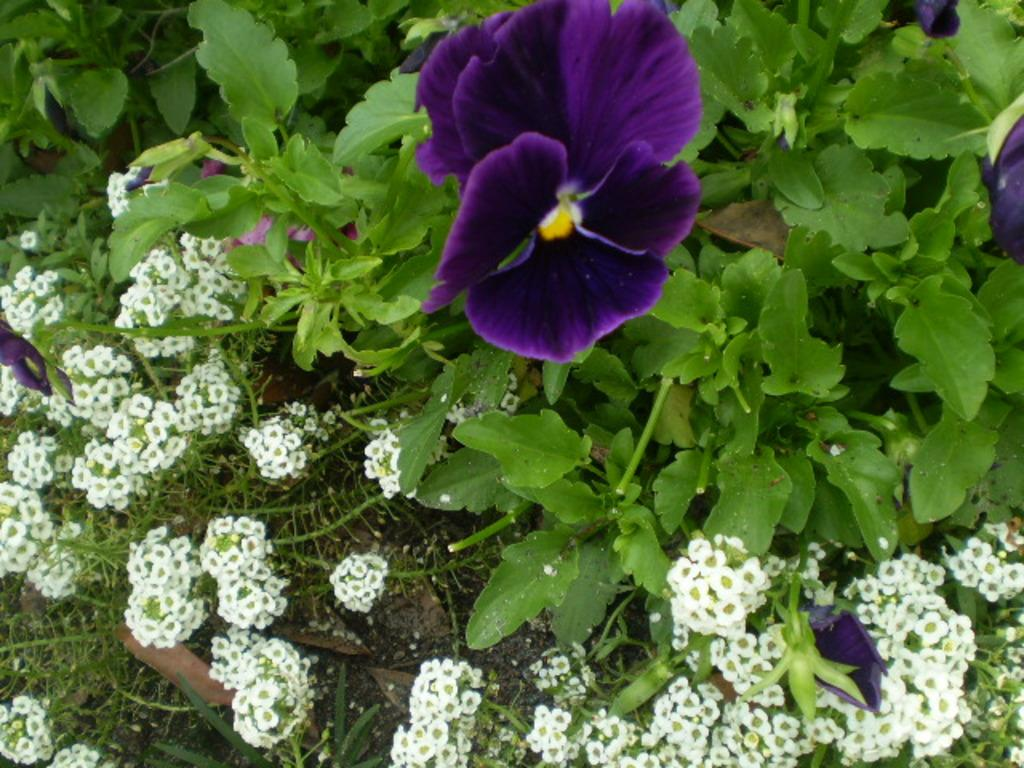What type of plants are present in the image? There are floral plants in the image. What news is being reported on the back of the floral plants in the image? There is no news or any other text present on the floral plants in the image. 